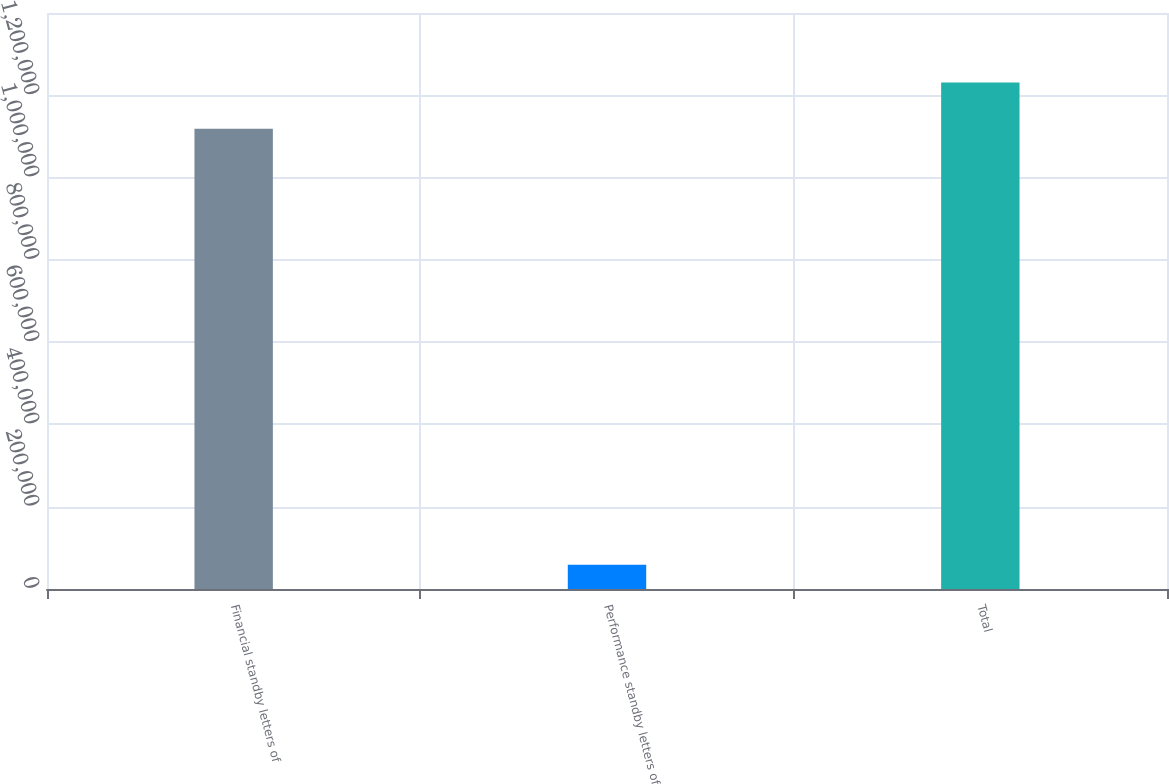Convert chart to OTSL. <chart><loc_0><loc_0><loc_500><loc_500><bar_chart><fcel>Financial standby letters of<fcel>Performance standby letters of<fcel>Total<nl><fcel>1.11855e+06<fcel>59034<fcel>1.23103e+06<nl></chart> 